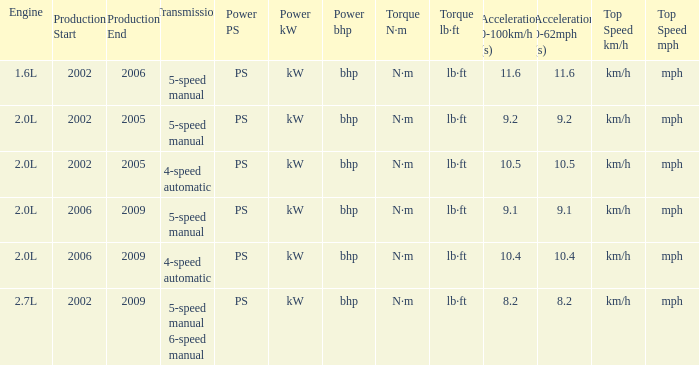What is the acceleration 0-100km/h that was produced in 2002-2006? 11.6 s. 